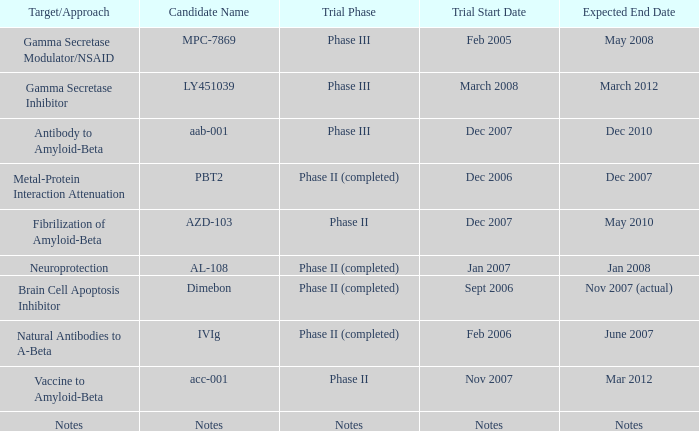What is Expected End Date, when Trial Start Date is Nov 2007? Mar 2012. 